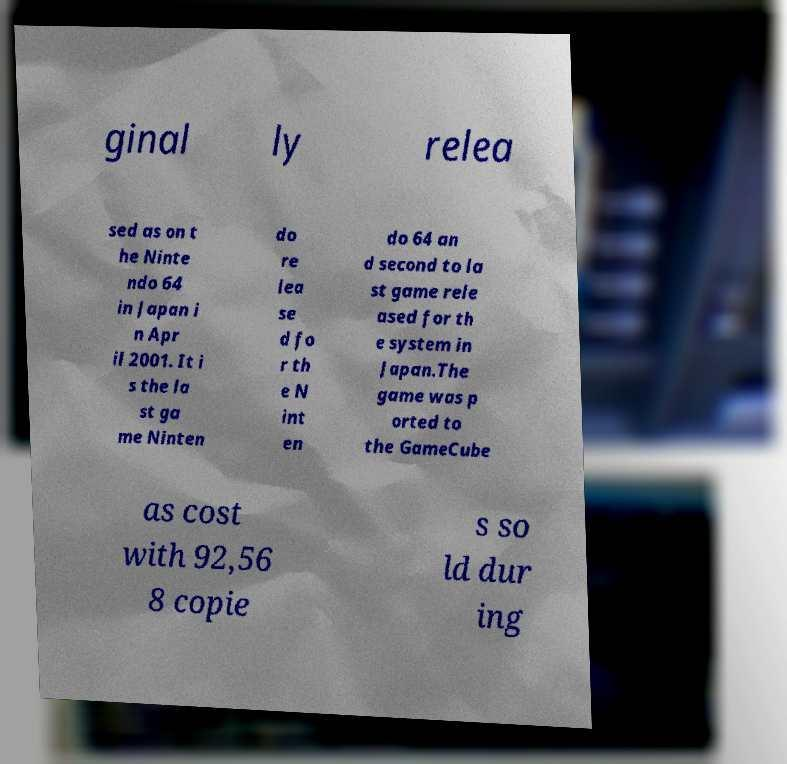There's text embedded in this image that I need extracted. Can you transcribe it verbatim? ginal ly relea sed as on t he Ninte ndo 64 in Japan i n Apr il 2001. It i s the la st ga me Ninten do re lea se d fo r th e N int en do 64 an d second to la st game rele ased for th e system in Japan.The game was p orted to the GameCube as cost with 92,56 8 copie s so ld dur ing 